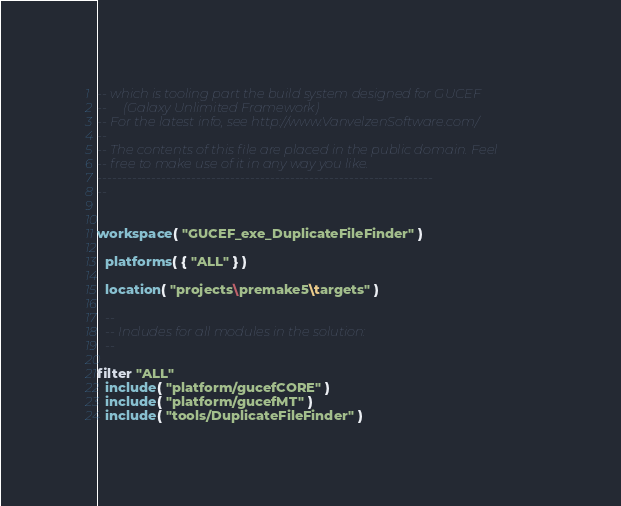Convert code to text. <code><loc_0><loc_0><loc_500><loc_500><_Lua_>-- which is tooling part the build system designed for GUCEF
--     (Galaxy Unlimited Framework)
-- For the latest info, see http://www.VanvelzenSoftware.com/
--
-- The contents of this file are placed in the public domain. Feel
-- free to make use of it in any way you like.
--------------------------------------------------------------------
--


workspace( "GUCEF_exe_DuplicateFileFinder" )

  platforms( { "ALL" } )

  location( "projects\premake5\targets" )

  --
  -- Includes for all modules in the solution:
  --

filter "ALL"
  include( "platform/gucefCORE" )
  include( "platform/gucefMT" )
  include( "tools/DuplicateFileFinder" )
</code> 